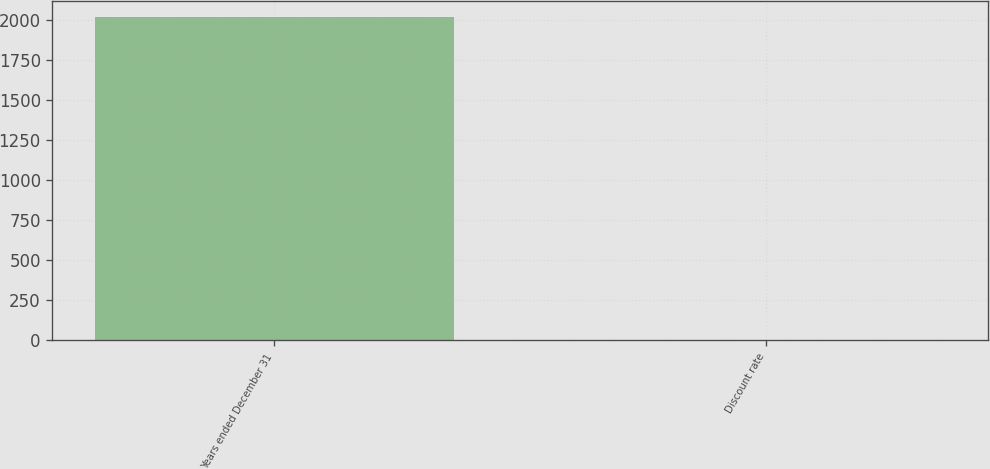Convert chart. <chart><loc_0><loc_0><loc_500><loc_500><bar_chart><fcel>Years ended December 31<fcel>Discount rate<nl><fcel>2016<fcel>4.65<nl></chart> 